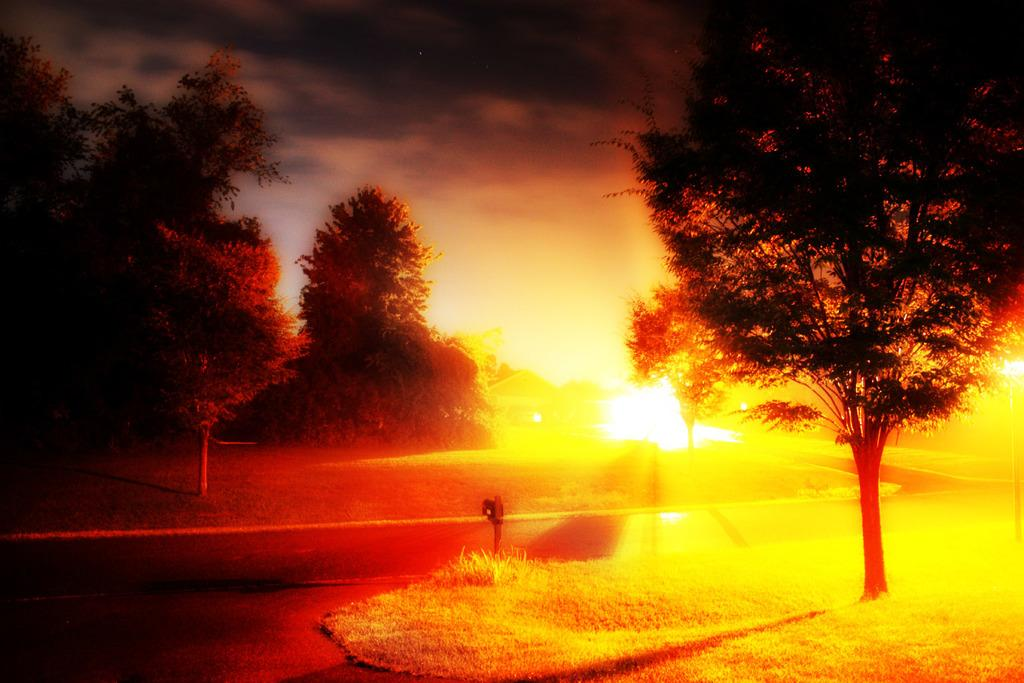What type of surface can be seen in the image? There is a road in the image. What type of vegetation is present in the image? There is grass and trees in the image. What is visible in the background of the image? The sky is visible in the image. What can be seen in the sky? Clouds are present in the sky. Who is the representative of the clouds in the image? There is no representative of the clouds in the image, as clouds are a natural phenomenon and not a person or entity. 